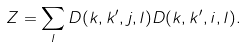Convert formula to latex. <formula><loc_0><loc_0><loc_500><loc_500>Z = \sum _ { l } D ( k , k ^ { \prime } , j , l ) D ( k , k ^ { \prime } , i , l ) .</formula> 